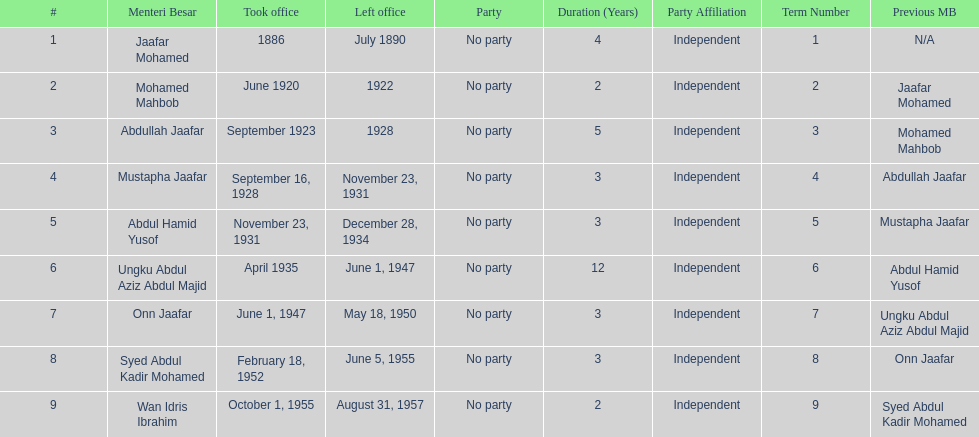Who succeeded mustapha jaafar in office? Abdul Hamid Yusof. 